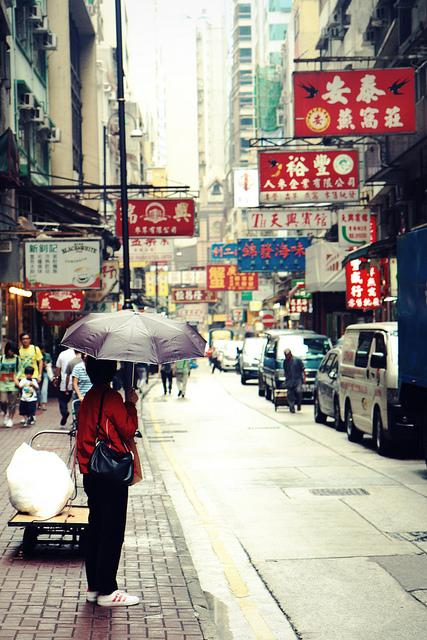Who is the maker of the white shoes? adidas 